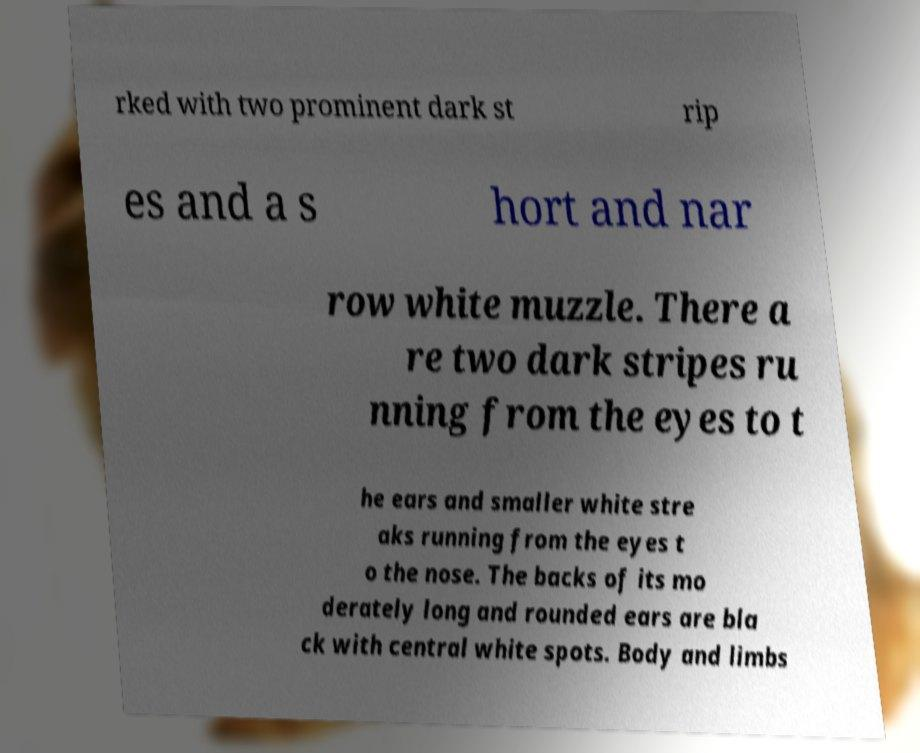Please identify and transcribe the text found in this image. rked with two prominent dark st rip es and a s hort and nar row white muzzle. There a re two dark stripes ru nning from the eyes to t he ears and smaller white stre aks running from the eyes t o the nose. The backs of its mo derately long and rounded ears are bla ck with central white spots. Body and limbs 